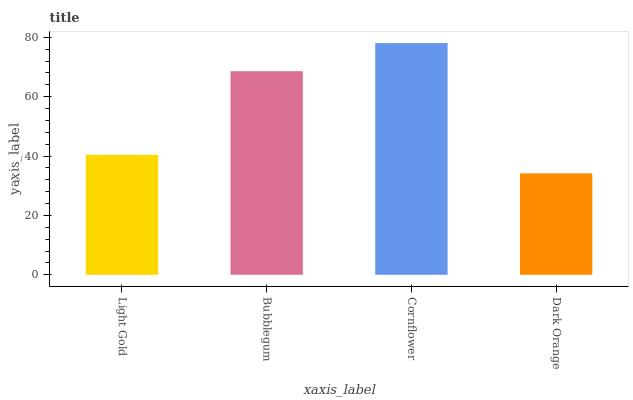Is Bubblegum the minimum?
Answer yes or no. No. Is Bubblegum the maximum?
Answer yes or no. No. Is Bubblegum greater than Light Gold?
Answer yes or no. Yes. Is Light Gold less than Bubblegum?
Answer yes or no. Yes. Is Light Gold greater than Bubblegum?
Answer yes or no. No. Is Bubblegum less than Light Gold?
Answer yes or no. No. Is Bubblegum the high median?
Answer yes or no. Yes. Is Light Gold the low median?
Answer yes or no. Yes. Is Light Gold the high median?
Answer yes or no. No. Is Dark Orange the low median?
Answer yes or no. No. 